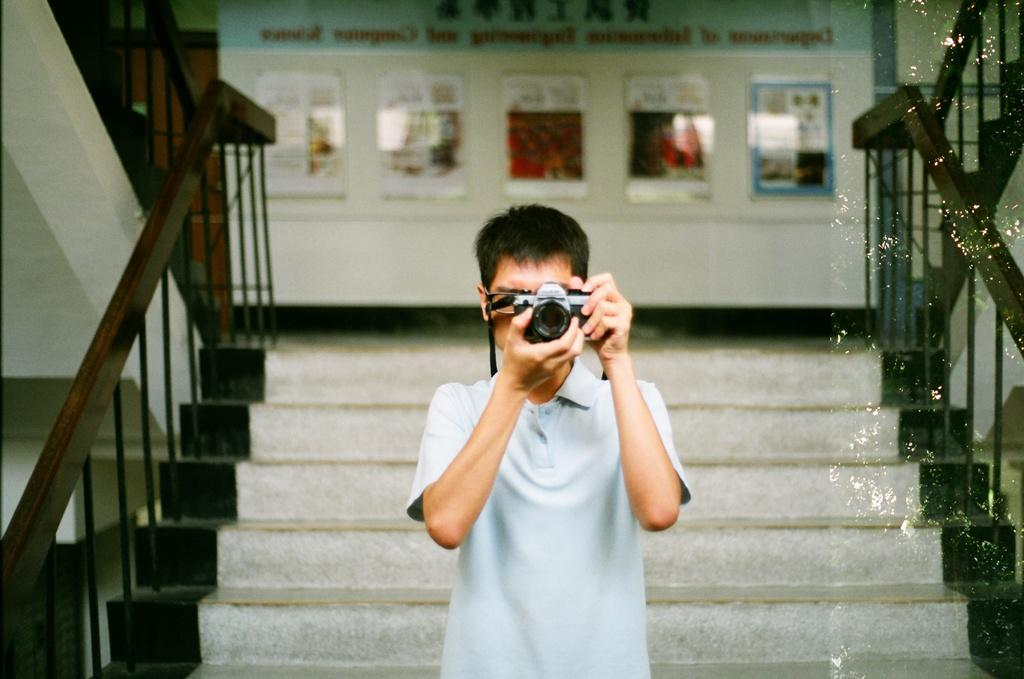What is the man in the image doing? The man is standing in the image and holding a camera. What can be seen on the wall in the image? There are posters on the wall. Are there any architectural features in the image? Yes, there are steps in the image. What type of polish is the man applying to the hearing aid in the image? There is no mention of a hearing aid or polish in the image; the man is holding a camera. 